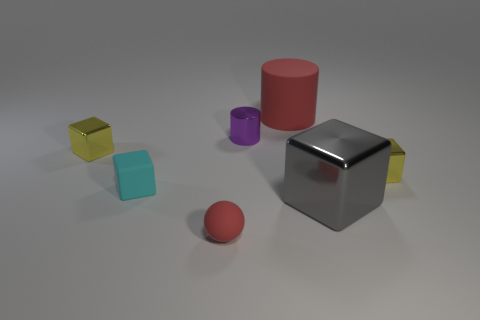What is the small yellow thing that is right of the small cube in front of the yellow metal cube on the right side of the large red cylinder made of?
Offer a terse response. Metal. Is there a tiny shiny object that has the same color as the small matte ball?
Your answer should be compact. No. Are there fewer yellow metal things that are on the left side of the tiny ball than large green balls?
Ensure brevity in your answer.  No. Is the size of the red matte object to the right of the red sphere the same as the tiny cyan object?
Provide a succinct answer. No. What number of objects are both behind the tiny purple cylinder and to the left of the tiny cyan block?
Your response must be concise. 0. There is a metal cube that is behind the yellow thing to the right of the big cylinder; what size is it?
Give a very brief answer. Small. Is the number of big gray things behind the tiny cyan cube less than the number of cyan objects behind the rubber cylinder?
Give a very brief answer. No. Do the object behind the tiny purple cylinder and the shiny block in front of the tiny cyan rubber cube have the same color?
Make the answer very short. No. What is the small thing that is both on the right side of the tiny matte sphere and in front of the tiny metallic cylinder made of?
Offer a terse response. Metal. Are any large metal objects visible?
Ensure brevity in your answer.  Yes. 